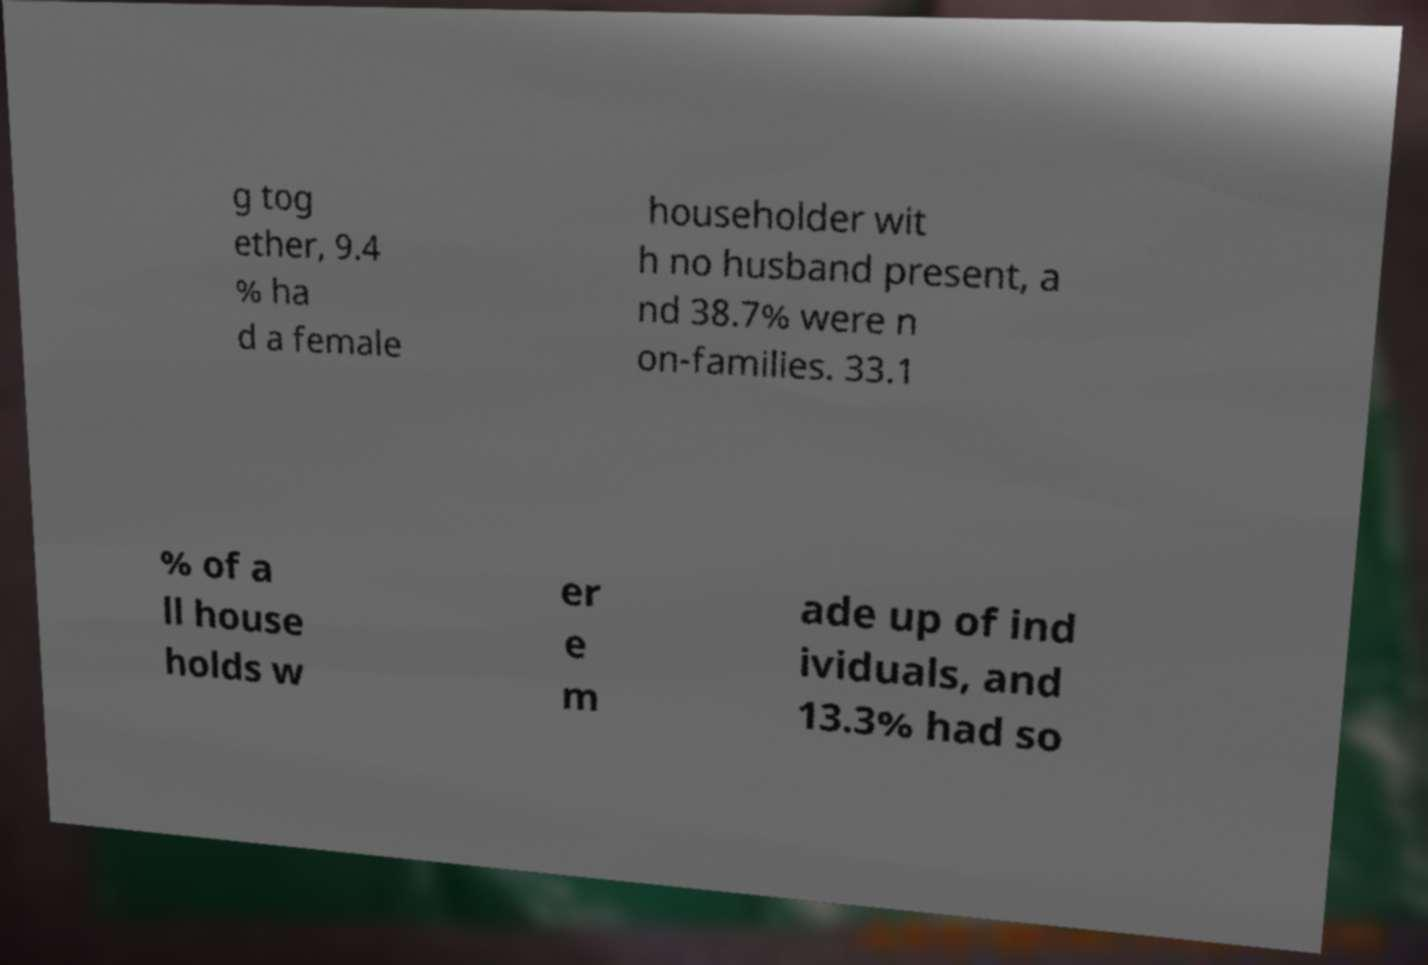Please read and relay the text visible in this image. What does it say? g tog ether, 9.4 % ha d a female householder wit h no husband present, a nd 38.7% were n on-families. 33.1 % of a ll house holds w er e m ade up of ind ividuals, and 13.3% had so 